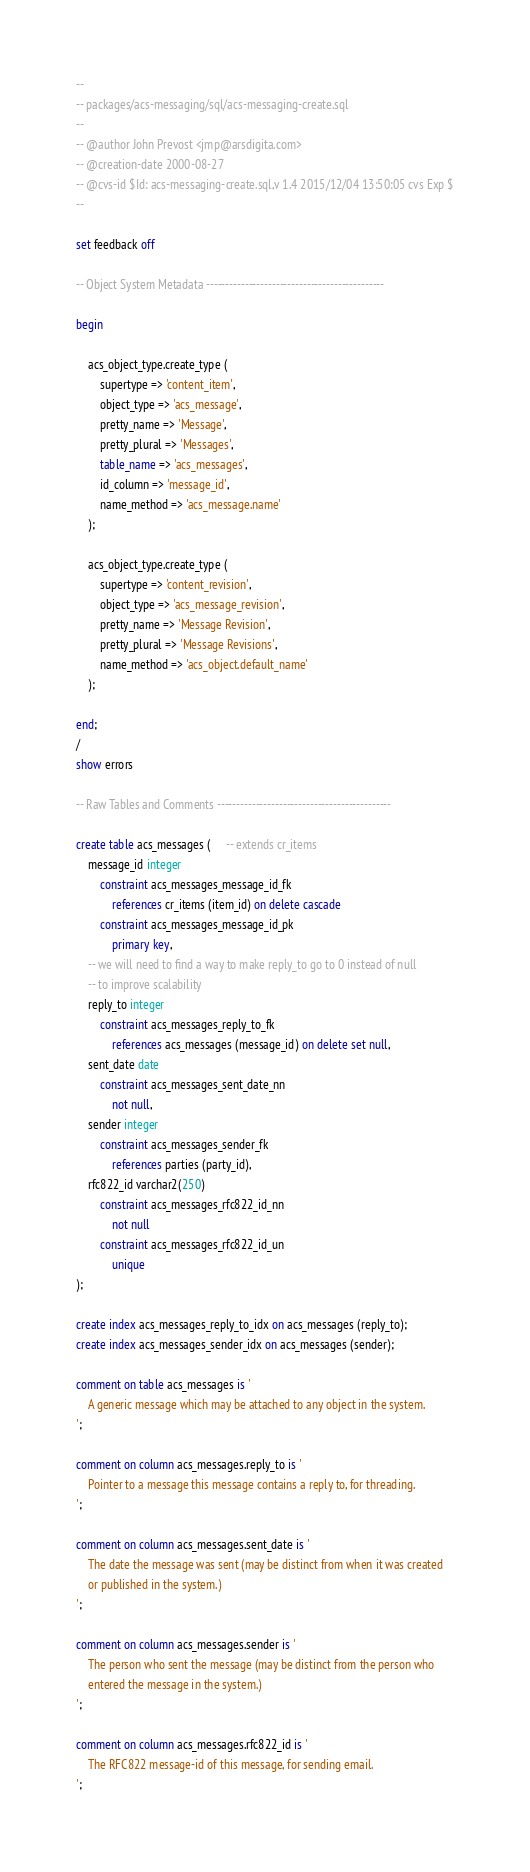<code> <loc_0><loc_0><loc_500><loc_500><_SQL_>--
-- packages/acs-messaging/sql/acs-messaging-create.sql
--
-- @author John Prevost <jmp@arsdigita.com>
-- @creation-date 2000-08-27
-- @cvs-id $Id: acs-messaging-create.sql,v 1.4 2015/12/04 13:50:05 cvs Exp $
--

set feedback off

-- Object System Metadata ----------------------------------------------

begin

    acs_object_type.create_type (
        supertype => 'content_item',
        object_type => 'acs_message',
        pretty_name => 'Message',
        pretty_plural => 'Messages',
        table_name => 'acs_messages',
        id_column => 'message_id',
        name_method => 'acs_message.name'
    );

    acs_object_type.create_type (
        supertype => 'content_revision',
        object_type => 'acs_message_revision',
        pretty_name => 'Message Revision',
        pretty_plural => 'Message Revisions',
        name_method => 'acs_object.default_name'
    );

end;
/
show errors

-- Raw Tables and Comments ---------------------------------------------

create table acs_messages (     -- extends cr_items
    message_id integer
        constraint acs_messages_message_id_fk
            references cr_items (item_id) on delete cascade
        constraint acs_messages_message_id_pk
            primary key,
    -- we will need to find a way to make reply_to go to 0 instead of null
    -- to improve scalability
    reply_to integer
        constraint acs_messages_reply_to_fk
            references acs_messages (message_id) on delete set null,
    sent_date date
        constraint acs_messages_sent_date_nn
            not null,
    sender integer
        constraint acs_messages_sender_fk
            references parties (party_id),
    rfc822_id varchar2(250)
        constraint acs_messages_rfc822_id_nn
            not null
        constraint acs_messages_rfc822_id_un
            unique
);

create index acs_messages_reply_to_idx on acs_messages (reply_to);
create index acs_messages_sender_idx on acs_messages (sender);

comment on table acs_messages is '
    A generic message which may be attached to any object in the system.
';

comment on column acs_messages.reply_to is '
    Pointer to a message this message contains a reply to, for threading.
';

comment on column acs_messages.sent_date is '
    The date the message was sent (may be distinct from when it was created
    or published in the system.)
';

comment on column acs_messages.sender is '
    The person who sent the message (may be distinct from the person who
    entered the message in the system.)
';

comment on column acs_messages.rfc822_id is '
    The RFC822 message-id of this message, for sending email.
';
</code> 